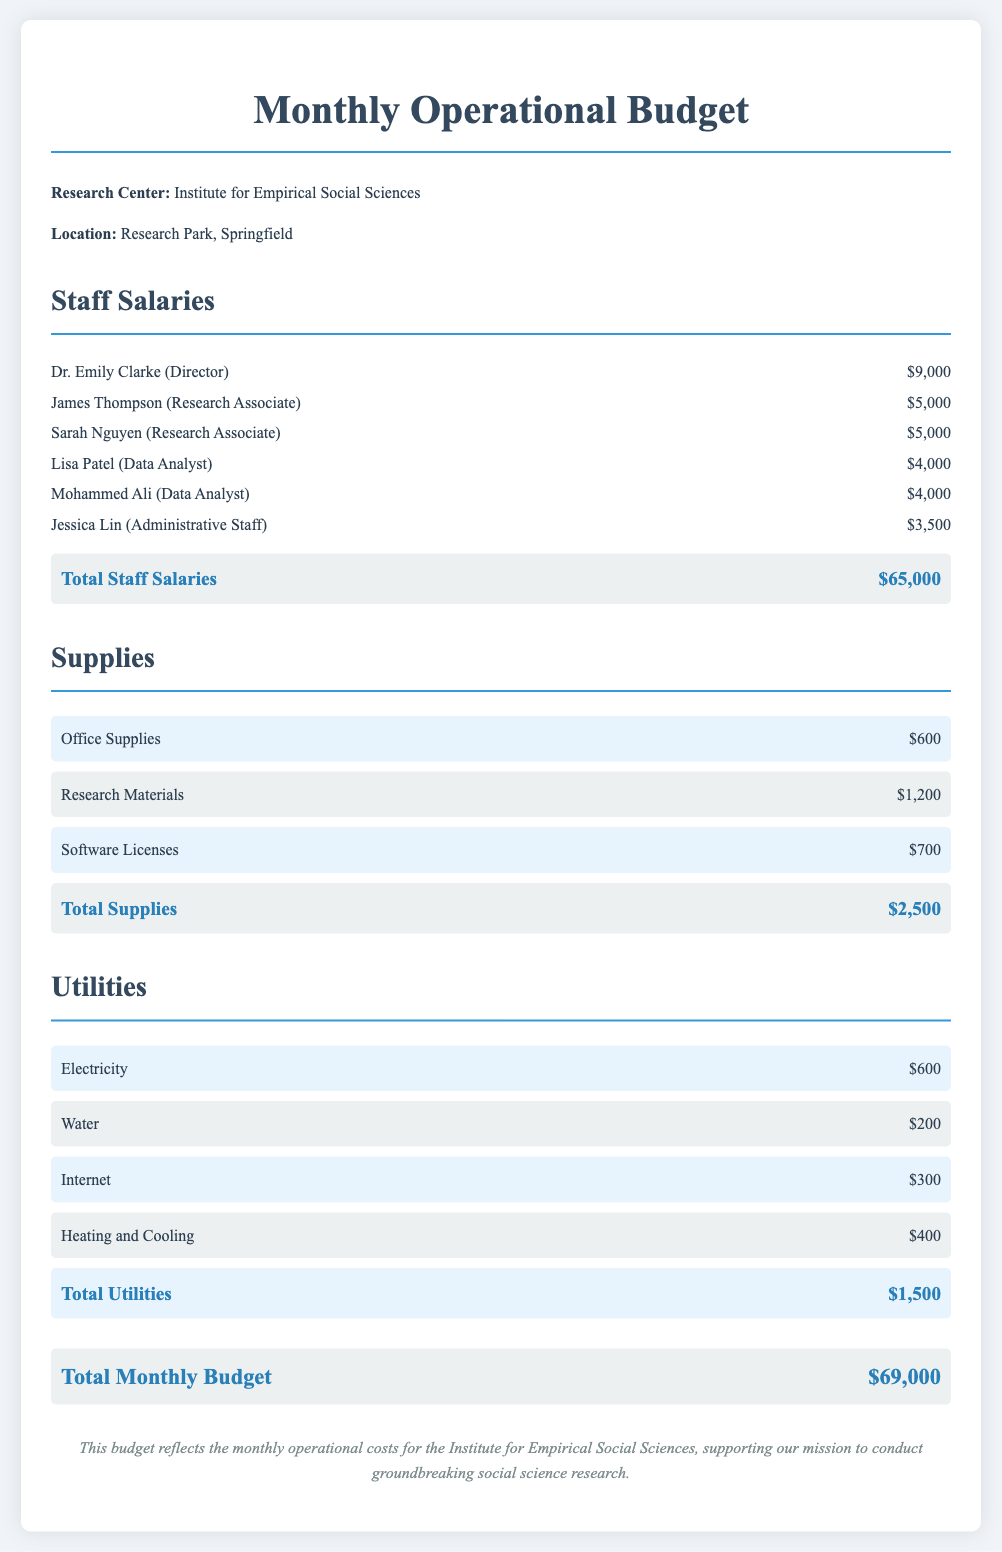What is the total amount for staff salaries? The total amount for staff salaries can be found in the 'Total Staff Salaries' section, which indicates $65,000.
Answer: $65,000 Who is the Director of the research center? The name of the Director can be identified in the staff list, which shows Dr. Emily Clarke as the Director.
Answer: Dr. Emily Clarke What is the cost of software licenses? The cost for software licenses is mentioned under the supplies section, listing it as $700.
Answer: $700 How much is allocated for Utilities in total? The total for Utilities is detailed in the budget section, which states $1,500.
Answer: $1,500 Which staff member has the lowest salary? The staff member with the lowest salary is shown in the staff list, which is Jessica Lin with a salary of $3,500.
Answer: Jessica Lin What is the budget allocated for research materials? The budget for research materials is specifically noted in the supplies section as $1,200.
Answer: $1,200 What is the total monthly budget? The total monthly budget is found at the end of the document, indicating the sum of all costs as $69,000.
Answer: $69,000 How many Research Associates are listed in the document? This can be determined from the staff list, which explicitly mentions two Research Associates: James Thompson and Sarah Nguyen.
Answer: 2 What is the monthly cost for Internet? The monthly cost for Internet can be found in the Utilities section, which states it as $300.
Answer: $300 